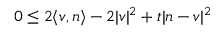Convert formula to latex. <formula><loc_0><loc_0><loc_500><loc_500>0 \leq 2 \langle v , n \rangle - 2 | v | ^ { 2 } + t | n - v | ^ { 2 }</formula> 